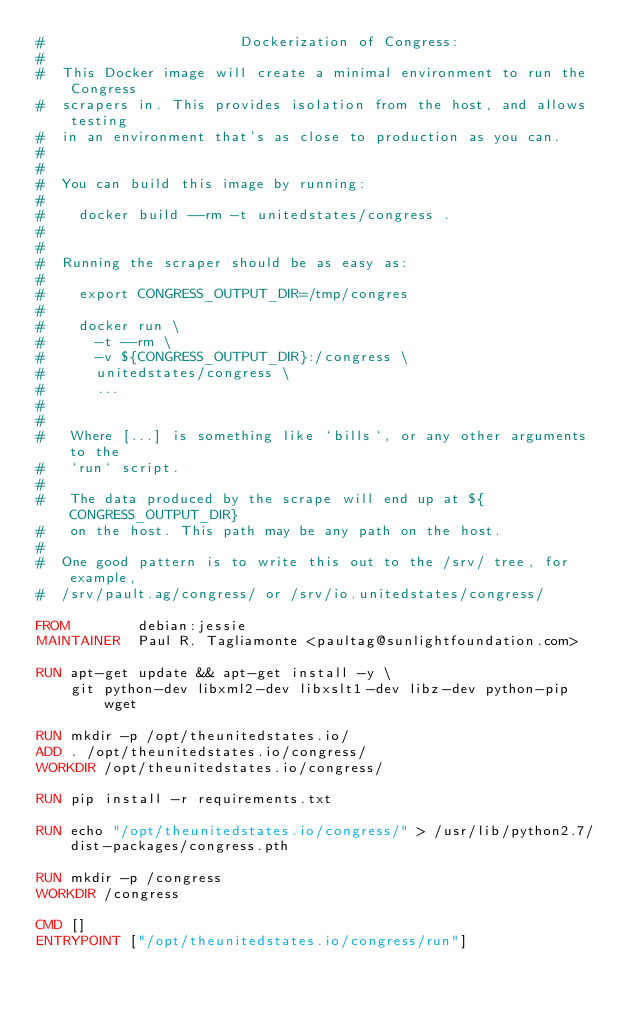Convert code to text. <code><loc_0><loc_0><loc_500><loc_500><_Dockerfile_>#                       Dockerization of Congress:
#
#  This Docker image will create a minimal environment to run the Congress
#  scrapers in. This provides isolation from the host, and allows testing
#  in an environment that's as close to production as you can.
#
#
#  You can build this image by running:
#
#    docker build --rm -t unitedstates/congress .
#
#
#  Running the scraper should be as easy as:
#
#    export CONGRESS_OUTPUT_DIR=/tmp/congres
#
#    docker run \
#      -t --rm \
#      -v ${CONGRESS_OUTPUT_DIR}:/congress \
#      unitedstates/congress \
#      ...
#
#
#   Where [...] is something like `bills`, or any other arguments to the
#   `run` script.
#
#   The data produced by the scrape will end up at ${CONGRESS_OUTPUT_DIR}
#   on the host. This path may be any path on the host.
#
#  One good pattern is to write this out to the /srv/ tree, for example,
#  /srv/pault.ag/congress/ or /srv/io.unitedstates/congress/

FROM        debian:jessie
MAINTAINER  Paul R. Tagliamonte <paultag@sunlightfoundation.com>

RUN apt-get update && apt-get install -y \
    git python-dev libxml2-dev libxslt1-dev libz-dev python-pip wget

RUN mkdir -p /opt/theunitedstates.io/
ADD . /opt/theunitedstates.io/congress/
WORKDIR /opt/theunitedstates.io/congress/

RUN pip install -r requirements.txt

RUN echo "/opt/theunitedstates.io/congress/" > /usr/lib/python2.7/dist-packages/congress.pth

RUN mkdir -p /congress
WORKDIR /congress

CMD []
ENTRYPOINT ["/opt/theunitedstates.io/congress/run"]
</code> 